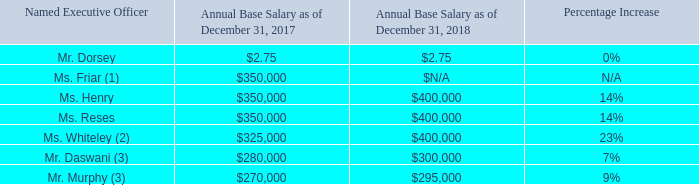Base Salary
Base salary for our named executive officers is the fixed component of our executive compensation program. We use base salary to compensate our named executive officers for services rendered during the year and to recognize the experience, skills, knowledge and responsibilities required of each named executive officer. We apply no specific formula to determine adjustments to base salary. Adjustments to base salary have been made to reflect our economic condition and future expected performance. We continue to provide base salaries that are conservative relative to competitive market pay levels.
In April 2018, our compensation committee reviewed the base salaries of Mses. Friar, Henry, Reses and Whiteley, taking into consideration a competitive market analysis performed by Compensia, the recommendations of our CEO and our then-current People Lead, the desire to retain our highly qualified executive team and the other factors described above. Following this review, our compensation committee approved an increase in the annual base salary levels for Mses. Friar, Henry, Reses and Whiteley to $400,000, in each case effective as of April 1, 2018, in order to improve competitive alignment with our peers. In addition, our compensation committee determined that it was appropriate to leave our CEO’s 2018 base salary level at $2.75 per year, at the request of our CEO and with compensation committee approval.
The annualized base salaries of our named executive officers as of December 31, 2018 compared to December 31, 2017 were:
(1) Ms. Friar resigned from her position as Chief Financial Officer, effective as of November 16, 2018, at which time her annual base salary was $400,000.
(2) Ms. Whiteley was appointed to General Counsel and Corporate Secretary effective March 18, 2018, and her salary was adjusted to reflect her promotion to this role.
(3) The base salaries of Messrs. Daswani and Murphy were not adjusted in conjunction with their service as interim co-CFOs. Salary adjustments for Messrs. Daswani and Murphy made in April 2018, prior to their becoming named executive officers, were made as part of the company-wide compensation review program. Their salary adjustments were recommended by their direct manager and approved by the then-current People Lead. Messrs. Daswani and Murphy’s annualized base salaries at the time of their appointment as interim co-CFOs were $300,000 and $295,000, respectively.
What is the annual base salary of Ms. Henry in 2017 and 2018 respectively? $350,000, $400,000. What is the annual base salary of Mr. Murphy in 2017 and 2018 respectively? $270,000, $295,000. What is the annual base salary of Mr. Daswini in 2017 and 2018 respectively? $280,000, $300,000. What is the difference in annual base salary in 2017 between Mr. Daswani and Mr. Murphy? 280,000-270,000
Answer: 10000. Which Executive Officer has the largest percentage increase in their annual base salary from 2017 to 2018? From COL5 find the largest number and the corresponding name(s) in COL2
Answer: ms. whiteley. What is the change in Ms Henry's annual base salary between 2017 and 2018? 400,000-350,000
Answer: 50000. 